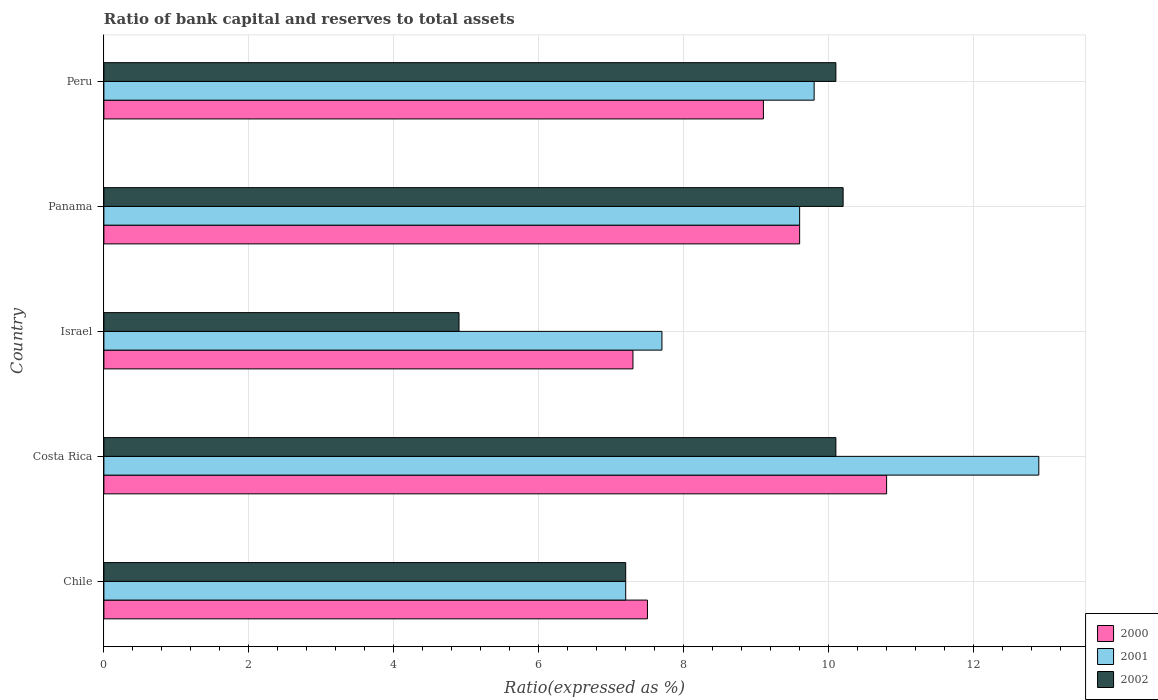How many different coloured bars are there?
Provide a succinct answer. 3. How many groups of bars are there?
Your answer should be compact. 5. Are the number of bars per tick equal to the number of legend labels?
Your response must be concise. Yes. Are the number of bars on each tick of the Y-axis equal?
Your answer should be compact. Yes. What is the label of the 5th group of bars from the top?
Your answer should be compact. Chile. Across all countries, what is the minimum ratio of bank capital and reserves to total assets in 2002?
Give a very brief answer. 4.9. In which country was the ratio of bank capital and reserves to total assets in 2002 minimum?
Keep it short and to the point. Israel. What is the total ratio of bank capital and reserves to total assets in 2002 in the graph?
Your answer should be very brief. 42.5. What is the difference between the ratio of bank capital and reserves to total assets in 2000 in Israel and that in Peru?
Offer a terse response. -1.8. What is the difference between the ratio of bank capital and reserves to total assets in 2000 in Israel and the ratio of bank capital and reserves to total assets in 2002 in Chile?
Your answer should be compact. 0.1. What is the average ratio of bank capital and reserves to total assets in 2000 per country?
Your answer should be very brief. 8.86. What is the difference between the ratio of bank capital and reserves to total assets in 2001 and ratio of bank capital and reserves to total assets in 2000 in Israel?
Your response must be concise. 0.4. What is the ratio of the ratio of bank capital and reserves to total assets in 2002 in Costa Rica to that in Israel?
Your response must be concise. 2.06. Is the ratio of bank capital and reserves to total assets in 2000 in Israel less than that in Panama?
Your response must be concise. Yes. What is the difference between the highest and the second highest ratio of bank capital and reserves to total assets in 2001?
Your answer should be very brief. 3.1. What is the difference between the highest and the lowest ratio of bank capital and reserves to total assets in 2002?
Offer a very short reply. 5.3. In how many countries, is the ratio of bank capital and reserves to total assets in 2001 greater than the average ratio of bank capital and reserves to total assets in 2001 taken over all countries?
Offer a very short reply. 3. How many bars are there?
Ensure brevity in your answer.  15. Are all the bars in the graph horizontal?
Give a very brief answer. Yes. How many countries are there in the graph?
Your answer should be very brief. 5. Are the values on the major ticks of X-axis written in scientific E-notation?
Offer a very short reply. No. Does the graph contain grids?
Your answer should be very brief. Yes. Where does the legend appear in the graph?
Your answer should be very brief. Bottom right. How many legend labels are there?
Make the answer very short. 3. What is the title of the graph?
Your answer should be compact. Ratio of bank capital and reserves to total assets. What is the label or title of the X-axis?
Give a very brief answer. Ratio(expressed as %). What is the Ratio(expressed as %) of 2000 in Chile?
Provide a short and direct response. 7.5. What is the Ratio(expressed as %) of 2001 in Chile?
Your answer should be compact. 7.2. What is the Ratio(expressed as %) in 2002 in Chile?
Your answer should be compact. 7.2. What is the Ratio(expressed as %) in 2000 in Israel?
Offer a terse response. 7.3. What is the Ratio(expressed as %) in 2001 in Israel?
Offer a very short reply. 7.7. What is the Ratio(expressed as %) in 2000 in Panama?
Make the answer very short. 9.6. Across all countries, what is the maximum Ratio(expressed as %) in 2000?
Provide a succinct answer. 10.8. Across all countries, what is the minimum Ratio(expressed as %) in 2000?
Provide a succinct answer. 7.3. Across all countries, what is the minimum Ratio(expressed as %) of 2001?
Offer a terse response. 7.2. What is the total Ratio(expressed as %) of 2000 in the graph?
Provide a short and direct response. 44.3. What is the total Ratio(expressed as %) in 2001 in the graph?
Make the answer very short. 47.2. What is the total Ratio(expressed as %) of 2002 in the graph?
Provide a short and direct response. 42.5. What is the difference between the Ratio(expressed as %) of 2000 in Chile and that in Costa Rica?
Provide a short and direct response. -3.3. What is the difference between the Ratio(expressed as %) in 2001 in Chile and that in Costa Rica?
Your answer should be very brief. -5.7. What is the difference between the Ratio(expressed as %) in 2000 in Chile and that in Israel?
Your response must be concise. 0.2. What is the difference between the Ratio(expressed as %) in 2001 in Chile and that in Israel?
Keep it short and to the point. -0.5. What is the difference between the Ratio(expressed as %) in 2002 in Chile and that in Israel?
Keep it short and to the point. 2.3. What is the difference between the Ratio(expressed as %) of 2000 in Chile and that in Panama?
Offer a terse response. -2.1. What is the difference between the Ratio(expressed as %) in 2000 in Chile and that in Peru?
Make the answer very short. -1.6. What is the difference between the Ratio(expressed as %) in 2001 in Chile and that in Peru?
Your response must be concise. -2.6. What is the difference between the Ratio(expressed as %) in 2002 in Chile and that in Peru?
Ensure brevity in your answer.  -2.9. What is the difference between the Ratio(expressed as %) of 2000 in Costa Rica and that in Israel?
Offer a terse response. 3.5. What is the difference between the Ratio(expressed as %) of 2001 in Costa Rica and that in Israel?
Provide a short and direct response. 5.2. What is the difference between the Ratio(expressed as %) of 2002 in Costa Rica and that in Israel?
Keep it short and to the point. 5.2. What is the difference between the Ratio(expressed as %) of 2002 in Costa Rica and that in Panama?
Offer a terse response. -0.1. What is the difference between the Ratio(expressed as %) of 2000 in Costa Rica and that in Peru?
Your response must be concise. 1.7. What is the difference between the Ratio(expressed as %) of 2001 in Costa Rica and that in Peru?
Your response must be concise. 3.1. What is the difference between the Ratio(expressed as %) of 2002 in Costa Rica and that in Peru?
Provide a short and direct response. 0. What is the difference between the Ratio(expressed as %) of 2000 in Israel and that in Panama?
Provide a succinct answer. -2.3. What is the difference between the Ratio(expressed as %) of 2001 in Israel and that in Panama?
Provide a short and direct response. -1.9. What is the difference between the Ratio(expressed as %) in 2000 in Israel and that in Peru?
Offer a very short reply. -1.8. What is the difference between the Ratio(expressed as %) in 2001 in Panama and that in Peru?
Keep it short and to the point. -0.2. What is the difference between the Ratio(expressed as %) of 2002 in Panama and that in Peru?
Your answer should be compact. 0.1. What is the difference between the Ratio(expressed as %) of 2000 in Chile and the Ratio(expressed as %) of 2002 in Costa Rica?
Offer a terse response. -2.6. What is the difference between the Ratio(expressed as %) of 2001 in Chile and the Ratio(expressed as %) of 2002 in Costa Rica?
Your answer should be very brief. -2.9. What is the difference between the Ratio(expressed as %) of 2001 in Chile and the Ratio(expressed as %) of 2002 in Panama?
Provide a short and direct response. -3. What is the difference between the Ratio(expressed as %) of 2000 in Chile and the Ratio(expressed as %) of 2002 in Peru?
Your response must be concise. -2.6. What is the difference between the Ratio(expressed as %) in 2001 in Costa Rica and the Ratio(expressed as %) in 2002 in Israel?
Your answer should be compact. 8. What is the difference between the Ratio(expressed as %) in 2000 in Costa Rica and the Ratio(expressed as %) in 2001 in Panama?
Give a very brief answer. 1.2. What is the difference between the Ratio(expressed as %) of 2000 in Costa Rica and the Ratio(expressed as %) of 2002 in Peru?
Make the answer very short. 0.7. What is the difference between the Ratio(expressed as %) in 2001 in Israel and the Ratio(expressed as %) in 2002 in Panama?
Offer a very short reply. -2.5. What is the difference between the Ratio(expressed as %) in 2000 in Israel and the Ratio(expressed as %) in 2002 in Peru?
Provide a succinct answer. -2.8. What is the difference between the Ratio(expressed as %) in 2000 in Panama and the Ratio(expressed as %) in 2001 in Peru?
Your answer should be compact. -0.2. What is the difference between the Ratio(expressed as %) of 2000 in Panama and the Ratio(expressed as %) of 2002 in Peru?
Your response must be concise. -0.5. What is the difference between the Ratio(expressed as %) of 2001 in Panama and the Ratio(expressed as %) of 2002 in Peru?
Ensure brevity in your answer.  -0.5. What is the average Ratio(expressed as %) in 2000 per country?
Give a very brief answer. 8.86. What is the average Ratio(expressed as %) of 2001 per country?
Give a very brief answer. 9.44. What is the average Ratio(expressed as %) in 2002 per country?
Your response must be concise. 8.5. What is the difference between the Ratio(expressed as %) of 2000 and Ratio(expressed as %) of 2001 in Chile?
Keep it short and to the point. 0.3. What is the difference between the Ratio(expressed as %) of 2000 and Ratio(expressed as %) of 2002 in Chile?
Offer a very short reply. 0.3. What is the difference between the Ratio(expressed as %) in 2001 and Ratio(expressed as %) in 2002 in Chile?
Make the answer very short. 0. What is the difference between the Ratio(expressed as %) of 2000 and Ratio(expressed as %) of 2001 in Costa Rica?
Provide a short and direct response. -2.1. What is the difference between the Ratio(expressed as %) of 2000 and Ratio(expressed as %) of 2001 in Panama?
Your answer should be compact. 0. What is the difference between the Ratio(expressed as %) of 2001 and Ratio(expressed as %) of 2002 in Panama?
Provide a succinct answer. -0.6. What is the difference between the Ratio(expressed as %) in 2000 and Ratio(expressed as %) in 2002 in Peru?
Provide a succinct answer. -1. What is the ratio of the Ratio(expressed as %) in 2000 in Chile to that in Costa Rica?
Provide a short and direct response. 0.69. What is the ratio of the Ratio(expressed as %) in 2001 in Chile to that in Costa Rica?
Give a very brief answer. 0.56. What is the ratio of the Ratio(expressed as %) of 2002 in Chile to that in Costa Rica?
Your answer should be very brief. 0.71. What is the ratio of the Ratio(expressed as %) in 2000 in Chile to that in Israel?
Give a very brief answer. 1.03. What is the ratio of the Ratio(expressed as %) of 2001 in Chile to that in Israel?
Offer a very short reply. 0.94. What is the ratio of the Ratio(expressed as %) in 2002 in Chile to that in Israel?
Provide a short and direct response. 1.47. What is the ratio of the Ratio(expressed as %) in 2000 in Chile to that in Panama?
Ensure brevity in your answer.  0.78. What is the ratio of the Ratio(expressed as %) of 2001 in Chile to that in Panama?
Make the answer very short. 0.75. What is the ratio of the Ratio(expressed as %) in 2002 in Chile to that in Panama?
Offer a very short reply. 0.71. What is the ratio of the Ratio(expressed as %) in 2000 in Chile to that in Peru?
Provide a short and direct response. 0.82. What is the ratio of the Ratio(expressed as %) in 2001 in Chile to that in Peru?
Ensure brevity in your answer.  0.73. What is the ratio of the Ratio(expressed as %) of 2002 in Chile to that in Peru?
Give a very brief answer. 0.71. What is the ratio of the Ratio(expressed as %) in 2000 in Costa Rica to that in Israel?
Offer a very short reply. 1.48. What is the ratio of the Ratio(expressed as %) of 2001 in Costa Rica to that in Israel?
Your answer should be compact. 1.68. What is the ratio of the Ratio(expressed as %) in 2002 in Costa Rica to that in Israel?
Keep it short and to the point. 2.06. What is the ratio of the Ratio(expressed as %) of 2000 in Costa Rica to that in Panama?
Ensure brevity in your answer.  1.12. What is the ratio of the Ratio(expressed as %) of 2001 in Costa Rica to that in Panama?
Your response must be concise. 1.34. What is the ratio of the Ratio(expressed as %) in 2002 in Costa Rica to that in Panama?
Make the answer very short. 0.99. What is the ratio of the Ratio(expressed as %) of 2000 in Costa Rica to that in Peru?
Your answer should be compact. 1.19. What is the ratio of the Ratio(expressed as %) of 2001 in Costa Rica to that in Peru?
Ensure brevity in your answer.  1.32. What is the ratio of the Ratio(expressed as %) of 2002 in Costa Rica to that in Peru?
Your answer should be compact. 1. What is the ratio of the Ratio(expressed as %) of 2000 in Israel to that in Panama?
Your answer should be very brief. 0.76. What is the ratio of the Ratio(expressed as %) of 2001 in Israel to that in Panama?
Give a very brief answer. 0.8. What is the ratio of the Ratio(expressed as %) of 2002 in Israel to that in Panama?
Ensure brevity in your answer.  0.48. What is the ratio of the Ratio(expressed as %) in 2000 in Israel to that in Peru?
Ensure brevity in your answer.  0.8. What is the ratio of the Ratio(expressed as %) in 2001 in Israel to that in Peru?
Provide a short and direct response. 0.79. What is the ratio of the Ratio(expressed as %) of 2002 in Israel to that in Peru?
Your answer should be compact. 0.49. What is the ratio of the Ratio(expressed as %) in 2000 in Panama to that in Peru?
Give a very brief answer. 1.05. What is the ratio of the Ratio(expressed as %) of 2001 in Panama to that in Peru?
Ensure brevity in your answer.  0.98. What is the ratio of the Ratio(expressed as %) in 2002 in Panama to that in Peru?
Ensure brevity in your answer.  1.01. What is the difference between the highest and the second highest Ratio(expressed as %) in 2000?
Make the answer very short. 1.2. What is the difference between the highest and the second highest Ratio(expressed as %) in 2001?
Give a very brief answer. 3.1. What is the difference between the highest and the lowest Ratio(expressed as %) in 2002?
Your answer should be very brief. 5.3. 